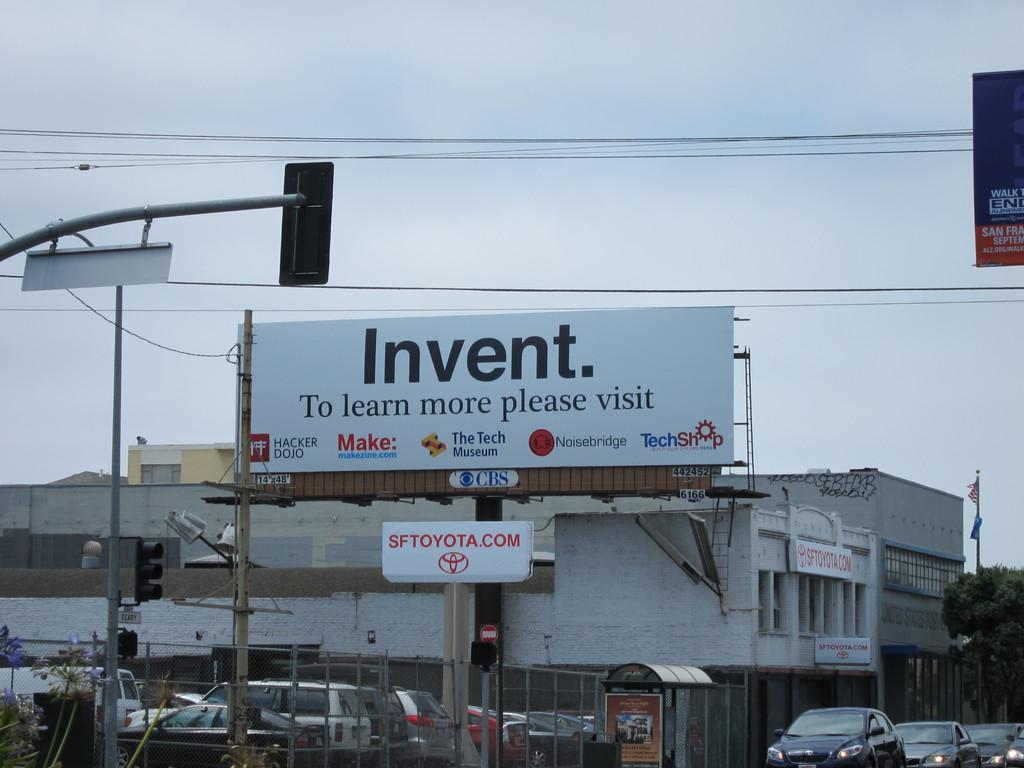<image>
Provide a brief description of the given image. A billboard in a busy part of town encourages people to invent things. 